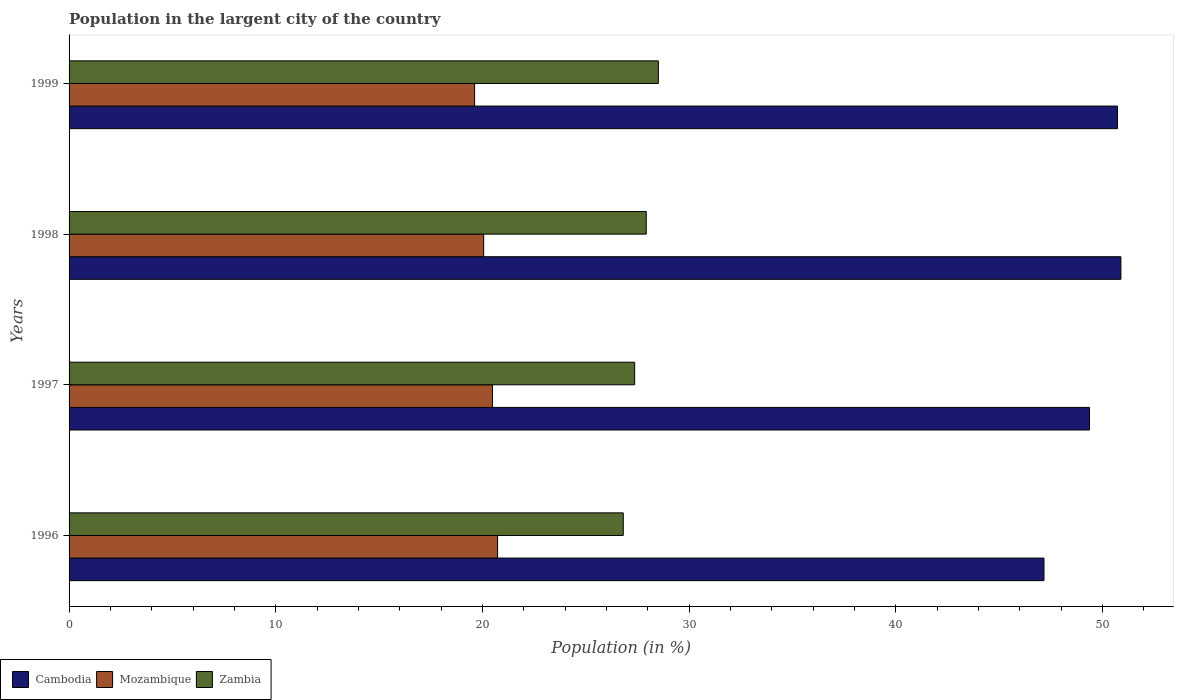How many different coloured bars are there?
Your answer should be very brief. 3. How many bars are there on the 3rd tick from the top?
Make the answer very short. 3. How many bars are there on the 3rd tick from the bottom?
Make the answer very short. 3. What is the percentage of population in the largent city in Cambodia in 1998?
Offer a very short reply. 50.9. Across all years, what is the maximum percentage of population in the largent city in Cambodia?
Provide a succinct answer. 50.9. Across all years, what is the minimum percentage of population in the largent city in Mozambique?
Give a very brief answer. 19.62. In which year was the percentage of population in the largent city in Mozambique maximum?
Provide a succinct answer. 1996. What is the total percentage of population in the largent city in Mozambique in the graph?
Offer a very short reply. 80.91. What is the difference between the percentage of population in the largent city in Mozambique in 1998 and that in 1999?
Offer a terse response. 0.44. What is the difference between the percentage of population in the largent city in Zambia in 1998 and the percentage of population in the largent city in Mozambique in 1999?
Make the answer very short. 8.31. What is the average percentage of population in the largent city in Mozambique per year?
Offer a terse response. 20.23. In the year 1998, what is the difference between the percentage of population in the largent city in Mozambique and percentage of population in the largent city in Cambodia?
Your response must be concise. -30.83. What is the ratio of the percentage of population in the largent city in Mozambique in 1998 to that in 1999?
Offer a very short reply. 1.02. Is the percentage of population in the largent city in Cambodia in 1996 less than that in 1997?
Provide a short and direct response. Yes. Is the difference between the percentage of population in the largent city in Mozambique in 1998 and 1999 greater than the difference between the percentage of population in the largent city in Cambodia in 1998 and 1999?
Give a very brief answer. Yes. What is the difference between the highest and the second highest percentage of population in the largent city in Zambia?
Keep it short and to the point. 0.59. What is the difference between the highest and the lowest percentage of population in the largent city in Cambodia?
Your response must be concise. 3.72. What does the 1st bar from the top in 1998 represents?
Keep it short and to the point. Zambia. What does the 3rd bar from the bottom in 1999 represents?
Your answer should be very brief. Zambia. Is it the case that in every year, the sum of the percentage of population in the largent city in Cambodia and percentage of population in the largent city in Mozambique is greater than the percentage of population in the largent city in Zambia?
Your answer should be compact. Yes. How many years are there in the graph?
Make the answer very short. 4. What is the difference between two consecutive major ticks on the X-axis?
Your answer should be compact. 10. Does the graph contain grids?
Provide a short and direct response. No. How are the legend labels stacked?
Ensure brevity in your answer.  Horizontal. What is the title of the graph?
Provide a succinct answer. Population in the largent city of the country. What is the label or title of the Y-axis?
Offer a terse response. Years. What is the Population (in %) in Cambodia in 1996?
Your response must be concise. 47.18. What is the Population (in %) in Mozambique in 1996?
Your response must be concise. 20.74. What is the Population (in %) in Zambia in 1996?
Provide a succinct answer. 26.82. What is the Population (in %) of Cambodia in 1997?
Provide a succinct answer. 49.38. What is the Population (in %) in Mozambique in 1997?
Keep it short and to the point. 20.49. What is the Population (in %) of Zambia in 1997?
Keep it short and to the point. 27.37. What is the Population (in %) of Cambodia in 1998?
Ensure brevity in your answer.  50.9. What is the Population (in %) in Mozambique in 1998?
Your answer should be compact. 20.06. What is the Population (in %) in Zambia in 1998?
Your answer should be very brief. 27.93. What is the Population (in %) in Cambodia in 1999?
Make the answer very short. 50.73. What is the Population (in %) of Mozambique in 1999?
Your response must be concise. 19.62. What is the Population (in %) of Zambia in 1999?
Offer a terse response. 28.52. Across all years, what is the maximum Population (in %) of Cambodia?
Offer a very short reply. 50.9. Across all years, what is the maximum Population (in %) of Mozambique?
Make the answer very short. 20.74. Across all years, what is the maximum Population (in %) in Zambia?
Offer a terse response. 28.52. Across all years, what is the minimum Population (in %) in Cambodia?
Provide a short and direct response. 47.18. Across all years, what is the minimum Population (in %) in Mozambique?
Make the answer very short. 19.62. Across all years, what is the minimum Population (in %) of Zambia?
Provide a succinct answer. 26.82. What is the total Population (in %) in Cambodia in the graph?
Make the answer very short. 198.18. What is the total Population (in %) in Mozambique in the graph?
Give a very brief answer. 80.91. What is the total Population (in %) in Zambia in the graph?
Make the answer very short. 110.63. What is the difference between the Population (in %) in Cambodia in 1996 and that in 1997?
Your answer should be very brief. -2.2. What is the difference between the Population (in %) in Mozambique in 1996 and that in 1997?
Keep it short and to the point. 0.25. What is the difference between the Population (in %) of Zambia in 1996 and that in 1997?
Offer a very short reply. -0.55. What is the difference between the Population (in %) in Cambodia in 1996 and that in 1998?
Provide a succinct answer. -3.72. What is the difference between the Population (in %) in Mozambique in 1996 and that in 1998?
Provide a succinct answer. 0.67. What is the difference between the Population (in %) of Zambia in 1996 and that in 1998?
Make the answer very short. -1.11. What is the difference between the Population (in %) in Cambodia in 1996 and that in 1999?
Ensure brevity in your answer.  -3.56. What is the difference between the Population (in %) in Mozambique in 1996 and that in 1999?
Give a very brief answer. 1.11. What is the difference between the Population (in %) in Zambia in 1996 and that in 1999?
Ensure brevity in your answer.  -1.7. What is the difference between the Population (in %) of Cambodia in 1997 and that in 1998?
Make the answer very short. -1.52. What is the difference between the Population (in %) in Mozambique in 1997 and that in 1998?
Make the answer very short. 0.43. What is the difference between the Population (in %) of Zambia in 1997 and that in 1998?
Keep it short and to the point. -0.56. What is the difference between the Population (in %) of Cambodia in 1997 and that in 1999?
Make the answer very short. -1.35. What is the difference between the Population (in %) in Mozambique in 1997 and that in 1999?
Your answer should be very brief. 0.87. What is the difference between the Population (in %) in Zambia in 1997 and that in 1999?
Offer a terse response. -1.15. What is the difference between the Population (in %) in Cambodia in 1998 and that in 1999?
Your answer should be very brief. 0.17. What is the difference between the Population (in %) of Mozambique in 1998 and that in 1999?
Keep it short and to the point. 0.44. What is the difference between the Population (in %) in Zambia in 1998 and that in 1999?
Offer a terse response. -0.58. What is the difference between the Population (in %) in Cambodia in 1996 and the Population (in %) in Mozambique in 1997?
Give a very brief answer. 26.69. What is the difference between the Population (in %) in Cambodia in 1996 and the Population (in %) in Zambia in 1997?
Offer a terse response. 19.81. What is the difference between the Population (in %) of Mozambique in 1996 and the Population (in %) of Zambia in 1997?
Offer a terse response. -6.63. What is the difference between the Population (in %) of Cambodia in 1996 and the Population (in %) of Mozambique in 1998?
Ensure brevity in your answer.  27.11. What is the difference between the Population (in %) of Cambodia in 1996 and the Population (in %) of Zambia in 1998?
Give a very brief answer. 19.25. What is the difference between the Population (in %) of Mozambique in 1996 and the Population (in %) of Zambia in 1998?
Provide a succinct answer. -7.19. What is the difference between the Population (in %) in Cambodia in 1996 and the Population (in %) in Mozambique in 1999?
Offer a terse response. 27.55. What is the difference between the Population (in %) of Cambodia in 1996 and the Population (in %) of Zambia in 1999?
Give a very brief answer. 18.66. What is the difference between the Population (in %) of Mozambique in 1996 and the Population (in %) of Zambia in 1999?
Provide a succinct answer. -7.78. What is the difference between the Population (in %) of Cambodia in 1997 and the Population (in %) of Mozambique in 1998?
Ensure brevity in your answer.  29.32. What is the difference between the Population (in %) of Cambodia in 1997 and the Population (in %) of Zambia in 1998?
Make the answer very short. 21.45. What is the difference between the Population (in %) of Mozambique in 1997 and the Population (in %) of Zambia in 1998?
Provide a short and direct response. -7.44. What is the difference between the Population (in %) of Cambodia in 1997 and the Population (in %) of Mozambique in 1999?
Your answer should be very brief. 29.75. What is the difference between the Population (in %) in Cambodia in 1997 and the Population (in %) in Zambia in 1999?
Ensure brevity in your answer.  20.86. What is the difference between the Population (in %) in Mozambique in 1997 and the Population (in %) in Zambia in 1999?
Offer a very short reply. -8.03. What is the difference between the Population (in %) in Cambodia in 1998 and the Population (in %) in Mozambique in 1999?
Provide a short and direct response. 31.27. What is the difference between the Population (in %) in Cambodia in 1998 and the Population (in %) in Zambia in 1999?
Your answer should be very brief. 22.38. What is the difference between the Population (in %) of Mozambique in 1998 and the Population (in %) of Zambia in 1999?
Give a very brief answer. -8.45. What is the average Population (in %) of Cambodia per year?
Your answer should be very brief. 49.55. What is the average Population (in %) of Mozambique per year?
Make the answer very short. 20.23. What is the average Population (in %) in Zambia per year?
Offer a terse response. 27.66. In the year 1996, what is the difference between the Population (in %) of Cambodia and Population (in %) of Mozambique?
Provide a succinct answer. 26.44. In the year 1996, what is the difference between the Population (in %) of Cambodia and Population (in %) of Zambia?
Provide a short and direct response. 20.36. In the year 1996, what is the difference between the Population (in %) of Mozambique and Population (in %) of Zambia?
Ensure brevity in your answer.  -6.08. In the year 1997, what is the difference between the Population (in %) of Cambodia and Population (in %) of Mozambique?
Provide a short and direct response. 28.89. In the year 1997, what is the difference between the Population (in %) in Cambodia and Population (in %) in Zambia?
Make the answer very short. 22.01. In the year 1997, what is the difference between the Population (in %) in Mozambique and Population (in %) in Zambia?
Ensure brevity in your answer.  -6.88. In the year 1998, what is the difference between the Population (in %) of Cambodia and Population (in %) of Mozambique?
Offer a terse response. 30.84. In the year 1998, what is the difference between the Population (in %) of Cambodia and Population (in %) of Zambia?
Offer a terse response. 22.97. In the year 1998, what is the difference between the Population (in %) in Mozambique and Population (in %) in Zambia?
Your response must be concise. -7.87. In the year 1999, what is the difference between the Population (in %) in Cambodia and Population (in %) in Mozambique?
Provide a succinct answer. 31.11. In the year 1999, what is the difference between the Population (in %) in Cambodia and Population (in %) in Zambia?
Offer a very short reply. 22.22. In the year 1999, what is the difference between the Population (in %) in Mozambique and Population (in %) in Zambia?
Offer a very short reply. -8.89. What is the ratio of the Population (in %) in Cambodia in 1996 to that in 1997?
Keep it short and to the point. 0.96. What is the ratio of the Population (in %) of Zambia in 1996 to that in 1997?
Provide a short and direct response. 0.98. What is the ratio of the Population (in %) of Cambodia in 1996 to that in 1998?
Keep it short and to the point. 0.93. What is the ratio of the Population (in %) in Mozambique in 1996 to that in 1998?
Make the answer very short. 1.03. What is the ratio of the Population (in %) of Zambia in 1996 to that in 1998?
Your answer should be compact. 0.96. What is the ratio of the Population (in %) in Cambodia in 1996 to that in 1999?
Your response must be concise. 0.93. What is the ratio of the Population (in %) of Mozambique in 1996 to that in 1999?
Make the answer very short. 1.06. What is the ratio of the Population (in %) of Zambia in 1996 to that in 1999?
Provide a short and direct response. 0.94. What is the ratio of the Population (in %) of Cambodia in 1997 to that in 1998?
Provide a short and direct response. 0.97. What is the ratio of the Population (in %) in Mozambique in 1997 to that in 1998?
Offer a terse response. 1.02. What is the ratio of the Population (in %) in Zambia in 1997 to that in 1998?
Offer a very short reply. 0.98. What is the ratio of the Population (in %) in Cambodia in 1997 to that in 1999?
Offer a terse response. 0.97. What is the ratio of the Population (in %) in Mozambique in 1997 to that in 1999?
Provide a succinct answer. 1.04. What is the ratio of the Population (in %) of Zambia in 1997 to that in 1999?
Your response must be concise. 0.96. What is the ratio of the Population (in %) of Cambodia in 1998 to that in 1999?
Offer a terse response. 1. What is the ratio of the Population (in %) in Mozambique in 1998 to that in 1999?
Provide a short and direct response. 1.02. What is the ratio of the Population (in %) in Zambia in 1998 to that in 1999?
Offer a very short reply. 0.98. What is the difference between the highest and the second highest Population (in %) of Cambodia?
Make the answer very short. 0.17. What is the difference between the highest and the second highest Population (in %) of Mozambique?
Ensure brevity in your answer.  0.25. What is the difference between the highest and the second highest Population (in %) in Zambia?
Offer a terse response. 0.58. What is the difference between the highest and the lowest Population (in %) in Cambodia?
Provide a short and direct response. 3.72. What is the difference between the highest and the lowest Population (in %) in Mozambique?
Ensure brevity in your answer.  1.11. What is the difference between the highest and the lowest Population (in %) in Zambia?
Ensure brevity in your answer.  1.7. 